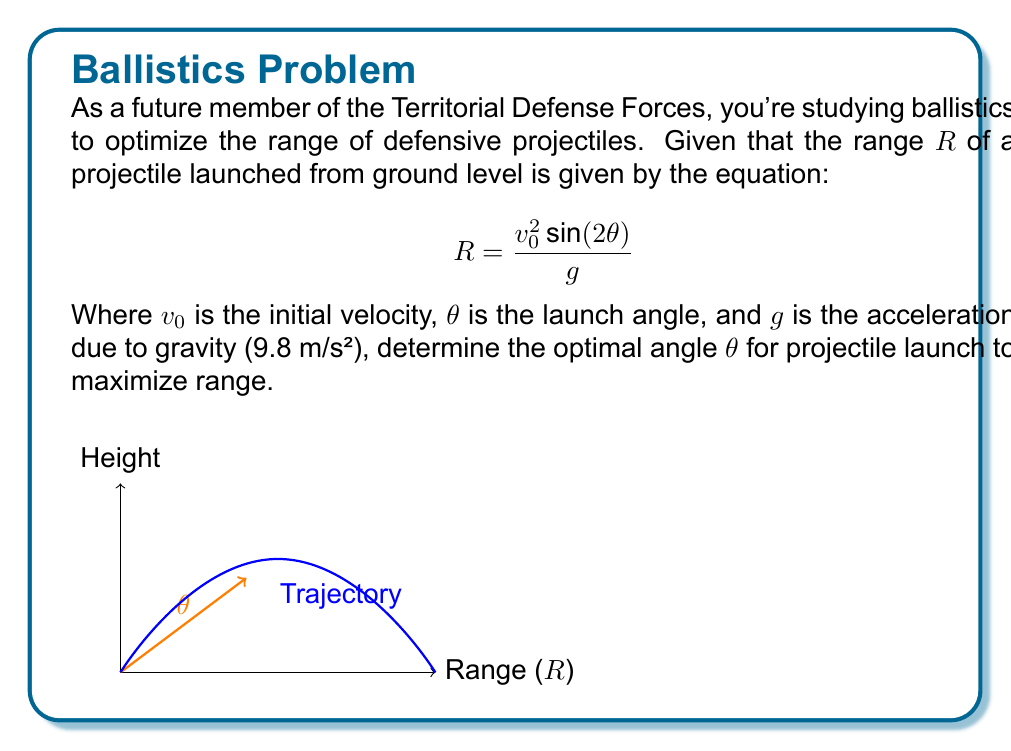What is the answer to this math problem? Let's approach this step-by-step:

1) The range equation is given as:
   $$R = \frac{v_0^2 \sin(2\theta)}{g}$$

2) To maximize R, we need to maximize $\sin(2\theta)$, as $v_0$ and $g$ are constants.

3) We know that the maximum value of sine function is 1, which occurs when its argument is 90° or $\frac{\pi}{2}$ radians.

4) So, we want:
   $$2\theta = \frac{\pi}{2}$$

5) Solving for $\theta$:
   $$\theta = \frac{\pi}{4} = 45°$$

6) We can verify this mathematically by taking the derivative of R with respect to $\theta$, setting it to zero, and solving for $\theta$, but this trigonometric approach is more straightforward.

7) Therefore, the optimal angle for projectile launch to maximize range is 45°.

This result is independent of the initial velocity and the gravitational acceleration, making it a universal principle in projectile motion.
Answer: 45° 